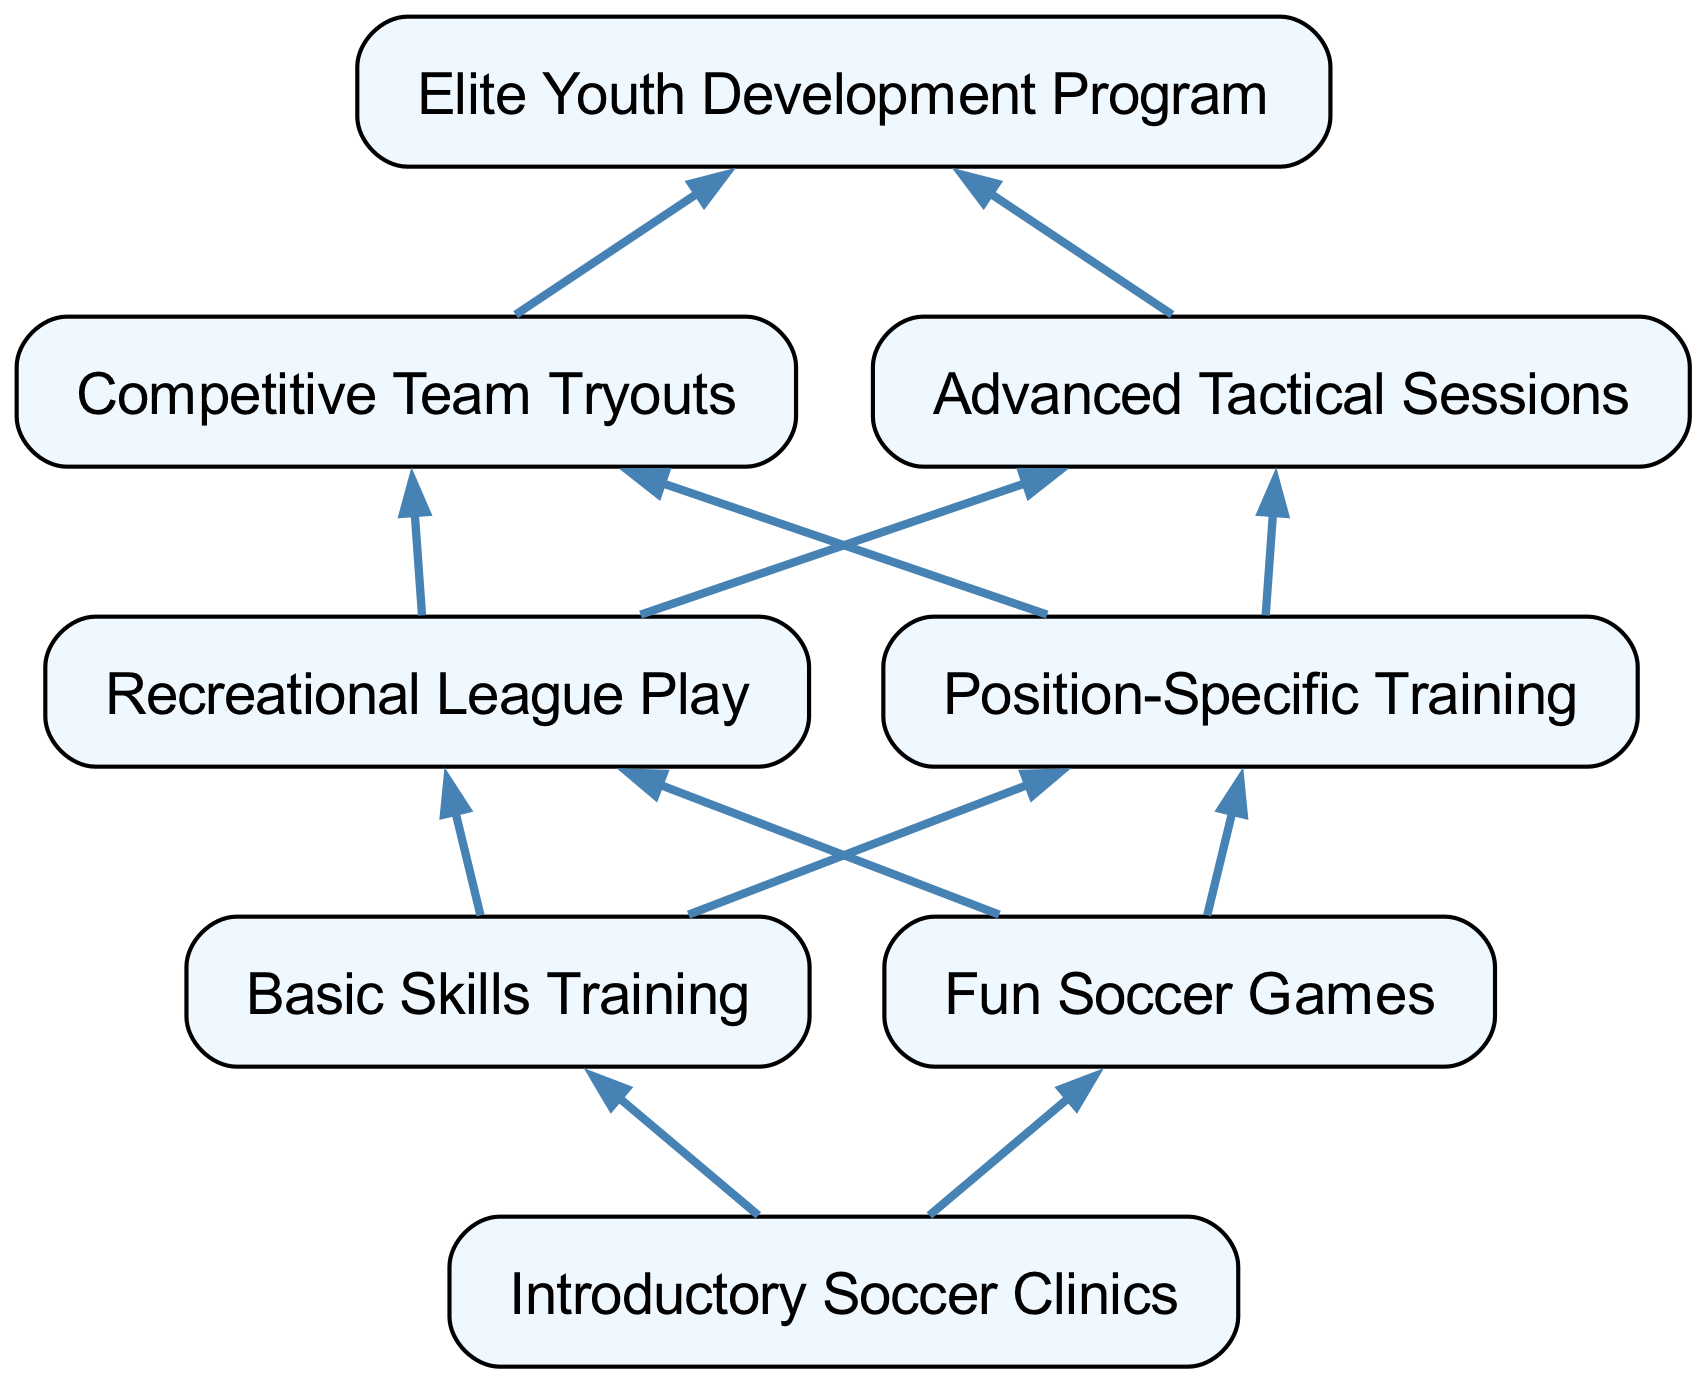What is the first step in the youth soccer program development? The diagram states that the first step in the development process is "Introductory Soccer Clinics", which is the starting node at the bottom of the flow chart.
Answer: Introductory Soccer Clinics How many main branches are there stemming from the introductory clinics? The introductory clinics are directly connected to two branches: "Basic Skills Training" and "Fun Soccer Games", so there are a total of two main branches.
Answer: 2 What is the final node in the flow chart? The last node in the flow chart, representing the ultimate goal of the development process, is "Elite Youth Development Program".
Answer: Elite Youth Development Program What type of training comes after "Fun Soccer Games"? The "Fun Soccer Games" leads to the same next steps as "Basic Skills Training", which are "Recreational League Play" and "Position-Specific Training", but since we are answering for after "Fun Soccer Games", the next node is "Recreational League Play".
Answer: Recreational League Play What are the two pathways after basic skills training in the youth soccer program? After "Basic Skills Training", the two pathways that emerge lead to "Recreational League Play" and "Position-Specific Training", giving participants options to specialize or engage in regular play.
Answer: Recreational League Play, Position-Specific Training What connects "Advanced Tactical Sessions" to the final program? "Advanced Tactical Sessions" connects to the "Elite Youth Development Program" node, indicating that it is part of the advanced training leading to the elite level of development.
Answer: Elite Youth Development Program How many total nodes are there in the diagram? The diagram lists a total of eight nodes, counting each distinct step from introductory clinics to the elite program, as shown without any omission.
Answer: 8 After "Competitive Team Tryouts", what is the next step? The subsequent step following the "Competitive Team Tryouts" is the "Elite Youth Development Program", which serves as the concluding goal of the competitive pathway.
Answer: Elite Youth Development Program 